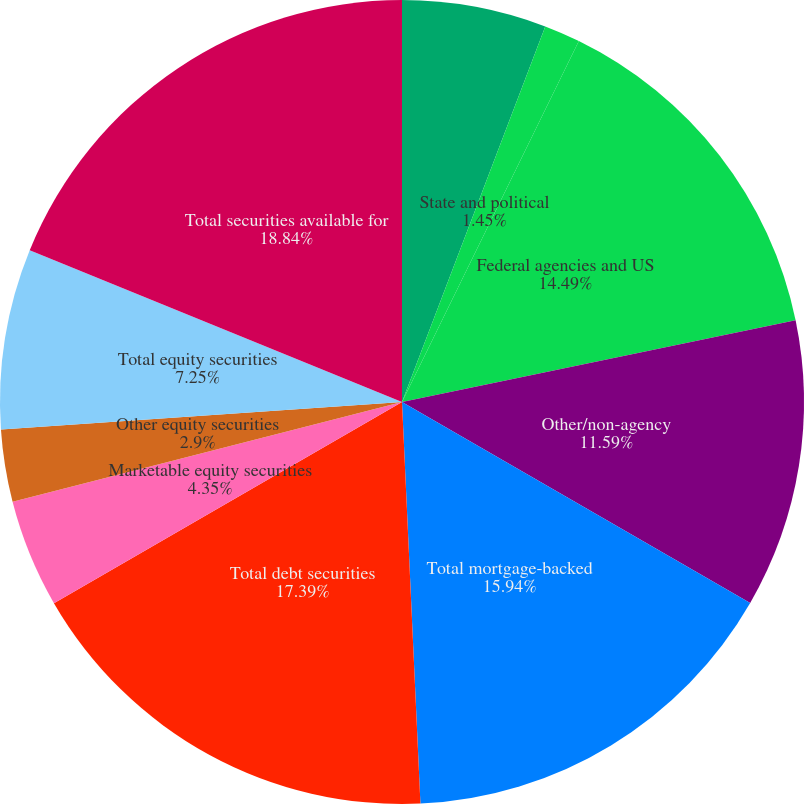<chart> <loc_0><loc_0><loc_500><loc_500><pie_chart><fcel>US Treasury<fcel>State and political<fcel>Federal agencies and US<fcel>Other/non-agency<fcel>Total mortgage-backed<fcel>Total debt securities<fcel>Marketable equity securities<fcel>Other equity securities<fcel>Total equity securities<fcel>Total securities available for<nl><fcel>5.8%<fcel>1.45%<fcel>14.49%<fcel>11.59%<fcel>15.94%<fcel>17.39%<fcel>4.35%<fcel>2.9%<fcel>7.25%<fcel>18.84%<nl></chart> 